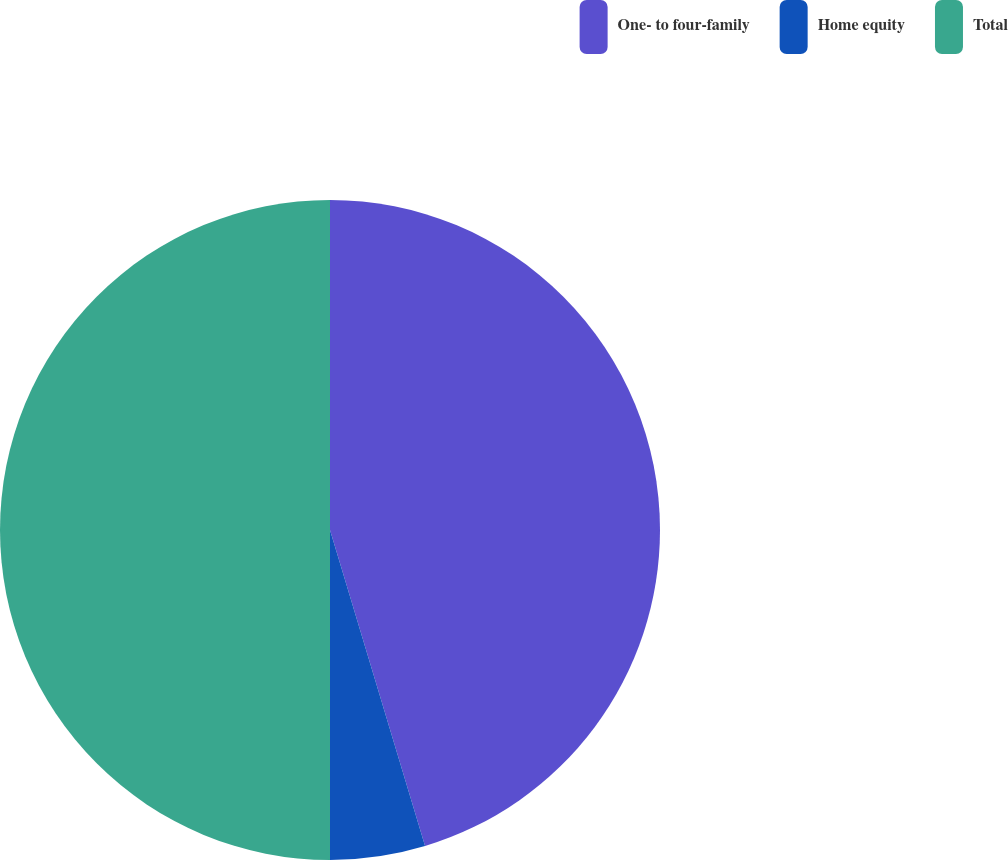Convert chart to OTSL. <chart><loc_0><loc_0><loc_500><loc_500><pie_chart><fcel>One- to four-family<fcel>Home equity<fcel>Total<nl><fcel>45.35%<fcel>4.65%<fcel>50.0%<nl></chart> 